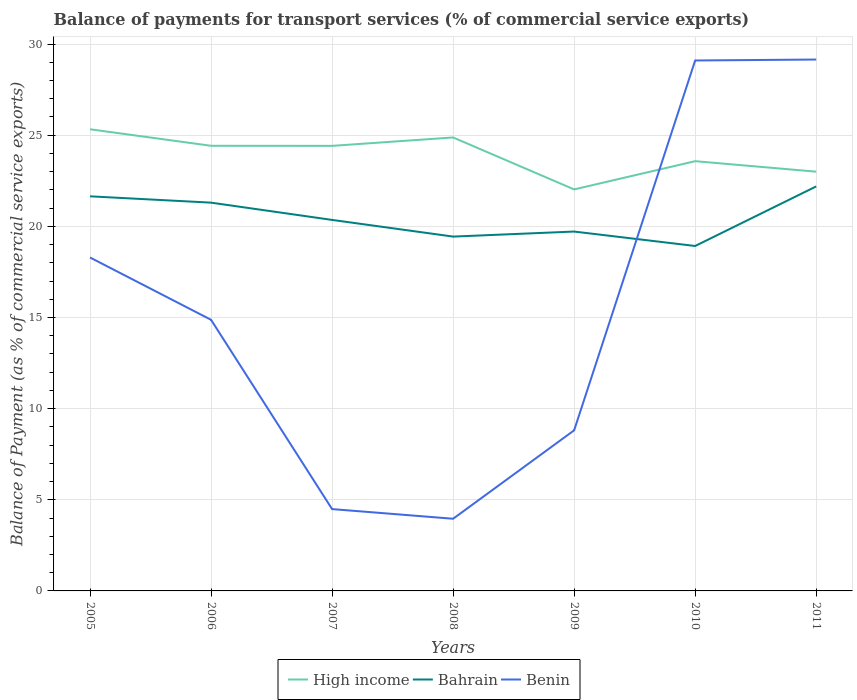Does the line corresponding to High income intersect with the line corresponding to Bahrain?
Make the answer very short. No. Is the number of lines equal to the number of legend labels?
Provide a short and direct response. Yes. Across all years, what is the maximum balance of payments for transport services in Benin?
Provide a succinct answer. 3.96. In which year was the balance of payments for transport services in High income maximum?
Your response must be concise. 2009. What is the total balance of payments for transport services in Benin in the graph?
Keep it short and to the point. -0.05. What is the difference between the highest and the second highest balance of payments for transport services in High income?
Ensure brevity in your answer.  3.3. How many lines are there?
Offer a very short reply. 3. What is the difference between two consecutive major ticks on the Y-axis?
Make the answer very short. 5. Where does the legend appear in the graph?
Your response must be concise. Bottom center. How are the legend labels stacked?
Your answer should be compact. Horizontal. What is the title of the graph?
Offer a very short reply. Balance of payments for transport services (% of commercial service exports). Does "Botswana" appear as one of the legend labels in the graph?
Give a very brief answer. No. What is the label or title of the X-axis?
Offer a terse response. Years. What is the label or title of the Y-axis?
Your response must be concise. Balance of Payment (as % of commercial service exports). What is the Balance of Payment (as % of commercial service exports) of High income in 2005?
Make the answer very short. 25.33. What is the Balance of Payment (as % of commercial service exports) in Bahrain in 2005?
Your response must be concise. 21.65. What is the Balance of Payment (as % of commercial service exports) of Benin in 2005?
Keep it short and to the point. 18.29. What is the Balance of Payment (as % of commercial service exports) of High income in 2006?
Your answer should be very brief. 24.42. What is the Balance of Payment (as % of commercial service exports) of Bahrain in 2006?
Your answer should be very brief. 21.3. What is the Balance of Payment (as % of commercial service exports) in Benin in 2006?
Your answer should be very brief. 14.87. What is the Balance of Payment (as % of commercial service exports) in High income in 2007?
Offer a very short reply. 24.42. What is the Balance of Payment (as % of commercial service exports) in Bahrain in 2007?
Your answer should be compact. 20.35. What is the Balance of Payment (as % of commercial service exports) of Benin in 2007?
Make the answer very short. 4.49. What is the Balance of Payment (as % of commercial service exports) in High income in 2008?
Offer a very short reply. 24.88. What is the Balance of Payment (as % of commercial service exports) of Bahrain in 2008?
Offer a very short reply. 19.44. What is the Balance of Payment (as % of commercial service exports) in Benin in 2008?
Give a very brief answer. 3.96. What is the Balance of Payment (as % of commercial service exports) in High income in 2009?
Make the answer very short. 22.03. What is the Balance of Payment (as % of commercial service exports) of Bahrain in 2009?
Offer a very short reply. 19.72. What is the Balance of Payment (as % of commercial service exports) of Benin in 2009?
Your response must be concise. 8.81. What is the Balance of Payment (as % of commercial service exports) in High income in 2010?
Your response must be concise. 23.58. What is the Balance of Payment (as % of commercial service exports) of Bahrain in 2010?
Give a very brief answer. 18.92. What is the Balance of Payment (as % of commercial service exports) of Benin in 2010?
Give a very brief answer. 29.1. What is the Balance of Payment (as % of commercial service exports) of High income in 2011?
Your response must be concise. 23. What is the Balance of Payment (as % of commercial service exports) in Bahrain in 2011?
Make the answer very short. 22.19. What is the Balance of Payment (as % of commercial service exports) in Benin in 2011?
Offer a very short reply. 29.15. Across all years, what is the maximum Balance of Payment (as % of commercial service exports) in High income?
Provide a short and direct response. 25.33. Across all years, what is the maximum Balance of Payment (as % of commercial service exports) of Bahrain?
Offer a terse response. 22.19. Across all years, what is the maximum Balance of Payment (as % of commercial service exports) of Benin?
Provide a short and direct response. 29.15. Across all years, what is the minimum Balance of Payment (as % of commercial service exports) in High income?
Your response must be concise. 22.03. Across all years, what is the minimum Balance of Payment (as % of commercial service exports) in Bahrain?
Make the answer very short. 18.92. Across all years, what is the minimum Balance of Payment (as % of commercial service exports) of Benin?
Your response must be concise. 3.96. What is the total Balance of Payment (as % of commercial service exports) in High income in the graph?
Make the answer very short. 167.64. What is the total Balance of Payment (as % of commercial service exports) of Bahrain in the graph?
Offer a terse response. 143.57. What is the total Balance of Payment (as % of commercial service exports) of Benin in the graph?
Offer a very short reply. 108.68. What is the difference between the Balance of Payment (as % of commercial service exports) in High income in 2005 and that in 2006?
Your answer should be very brief. 0.91. What is the difference between the Balance of Payment (as % of commercial service exports) in Bahrain in 2005 and that in 2006?
Your answer should be compact. 0.35. What is the difference between the Balance of Payment (as % of commercial service exports) of Benin in 2005 and that in 2006?
Your answer should be very brief. 3.42. What is the difference between the Balance of Payment (as % of commercial service exports) in High income in 2005 and that in 2007?
Offer a terse response. 0.91. What is the difference between the Balance of Payment (as % of commercial service exports) of Bahrain in 2005 and that in 2007?
Give a very brief answer. 1.29. What is the difference between the Balance of Payment (as % of commercial service exports) of Benin in 2005 and that in 2007?
Provide a succinct answer. 13.8. What is the difference between the Balance of Payment (as % of commercial service exports) in High income in 2005 and that in 2008?
Your answer should be very brief. 0.45. What is the difference between the Balance of Payment (as % of commercial service exports) of Bahrain in 2005 and that in 2008?
Your response must be concise. 2.21. What is the difference between the Balance of Payment (as % of commercial service exports) in Benin in 2005 and that in 2008?
Ensure brevity in your answer.  14.33. What is the difference between the Balance of Payment (as % of commercial service exports) in High income in 2005 and that in 2009?
Offer a very short reply. 3.3. What is the difference between the Balance of Payment (as % of commercial service exports) of Bahrain in 2005 and that in 2009?
Ensure brevity in your answer.  1.93. What is the difference between the Balance of Payment (as % of commercial service exports) in Benin in 2005 and that in 2009?
Ensure brevity in your answer.  9.48. What is the difference between the Balance of Payment (as % of commercial service exports) of High income in 2005 and that in 2010?
Offer a very short reply. 1.75. What is the difference between the Balance of Payment (as % of commercial service exports) in Bahrain in 2005 and that in 2010?
Make the answer very short. 2.73. What is the difference between the Balance of Payment (as % of commercial service exports) of Benin in 2005 and that in 2010?
Make the answer very short. -10.81. What is the difference between the Balance of Payment (as % of commercial service exports) of High income in 2005 and that in 2011?
Keep it short and to the point. 2.33. What is the difference between the Balance of Payment (as % of commercial service exports) in Bahrain in 2005 and that in 2011?
Your answer should be compact. -0.54. What is the difference between the Balance of Payment (as % of commercial service exports) in Benin in 2005 and that in 2011?
Ensure brevity in your answer.  -10.86. What is the difference between the Balance of Payment (as % of commercial service exports) in High income in 2006 and that in 2007?
Provide a succinct answer. 0. What is the difference between the Balance of Payment (as % of commercial service exports) in Bahrain in 2006 and that in 2007?
Your answer should be very brief. 0.95. What is the difference between the Balance of Payment (as % of commercial service exports) of Benin in 2006 and that in 2007?
Make the answer very short. 10.38. What is the difference between the Balance of Payment (as % of commercial service exports) of High income in 2006 and that in 2008?
Provide a short and direct response. -0.46. What is the difference between the Balance of Payment (as % of commercial service exports) in Bahrain in 2006 and that in 2008?
Make the answer very short. 1.86. What is the difference between the Balance of Payment (as % of commercial service exports) in Benin in 2006 and that in 2008?
Your answer should be compact. 10.91. What is the difference between the Balance of Payment (as % of commercial service exports) of High income in 2006 and that in 2009?
Your answer should be compact. 2.39. What is the difference between the Balance of Payment (as % of commercial service exports) of Bahrain in 2006 and that in 2009?
Offer a terse response. 1.59. What is the difference between the Balance of Payment (as % of commercial service exports) of Benin in 2006 and that in 2009?
Ensure brevity in your answer.  6.06. What is the difference between the Balance of Payment (as % of commercial service exports) of High income in 2006 and that in 2010?
Offer a terse response. 0.84. What is the difference between the Balance of Payment (as % of commercial service exports) in Bahrain in 2006 and that in 2010?
Give a very brief answer. 2.38. What is the difference between the Balance of Payment (as % of commercial service exports) in Benin in 2006 and that in 2010?
Give a very brief answer. -14.23. What is the difference between the Balance of Payment (as % of commercial service exports) of High income in 2006 and that in 2011?
Give a very brief answer. 1.42. What is the difference between the Balance of Payment (as % of commercial service exports) in Bahrain in 2006 and that in 2011?
Ensure brevity in your answer.  -0.89. What is the difference between the Balance of Payment (as % of commercial service exports) in Benin in 2006 and that in 2011?
Provide a short and direct response. -14.28. What is the difference between the Balance of Payment (as % of commercial service exports) of High income in 2007 and that in 2008?
Your response must be concise. -0.46. What is the difference between the Balance of Payment (as % of commercial service exports) of Bahrain in 2007 and that in 2008?
Provide a succinct answer. 0.92. What is the difference between the Balance of Payment (as % of commercial service exports) of Benin in 2007 and that in 2008?
Offer a terse response. 0.53. What is the difference between the Balance of Payment (as % of commercial service exports) in High income in 2007 and that in 2009?
Your answer should be very brief. 2.39. What is the difference between the Balance of Payment (as % of commercial service exports) of Bahrain in 2007 and that in 2009?
Give a very brief answer. 0.64. What is the difference between the Balance of Payment (as % of commercial service exports) in Benin in 2007 and that in 2009?
Provide a short and direct response. -4.32. What is the difference between the Balance of Payment (as % of commercial service exports) of High income in 2007 and that in 2010?
Offer a terse response. 0.84. What is the difference between the Balance of Payment (as % of commercial service exports) of Bahrain in 2007 and that in 2010?
Offer a very short reply. 1.43. What is the difference between the Balance of Payment (as % of commercial service exports) of Benin in 2007 and that in 2010?
Provide a short and direct response. -24.61. What is the difference between the Balance of Payment (as % of commercial service exports) in High income in 2007 and that in 2011?
Offer a very short reply. 1.42. What is the difference between the Balance of Payment (as % of commercial service exports) in Bahrain in 2007 and that in 2011?
Give a very brief answer. -1.84. What is the difference between the Balance of Payment (as % of commercial service exports) of Benin in 2007 and that in 2011?
Provide a succinct answer. -24.66. What is the difference between the Balance of Payment (as % of commercial service exports) of High income in 2008 and that in 2009?
Offer a very short reply. 2.85. What is the difference between the Balance of Payment (as % of commercial service exports) in Bahrain in 2008 and that in 2009?
Offer a very short reply. -0.28. What is the difference between the Balance of Payment (as % of commercial service exports) in Benin in 2008 and that in 2009?
Offer a very short reply. -4.85. What is the difference between the Balance of Payment (as % of commercial service exports) in High income in 2008 and that in 2010?
Your answer should be compact. 1.3. What is the difference between the Balance of Payment (as % of commercial service exports) in Bahrain in 2008 and that in 2010?
Your answer should be compact. 0.52. What is the difference between the Balance of Payment (as % of commercial service exports) of Benin in 2008 and that in 2010?
Offer a very short reply. -25.14. What is the difference between the Balance of Payment (as % of commercial service exports) of High income in 2008 and that in 2011?
Your response must be concise. 1.88. What is the difference between the Balance of Payment (as % of commercial service exports) in Bahrain in 2008 and that in 2011?
Keep it short and to the point. -2.75. What is the difference between the Balance of Payment (as % of commercial service exports) of Benin in 2008 and that in 2011?
Provide a short and direct response. -25.19. What is the difference between the Balance of Payment (as % of commercial service exports) in High income in 2009 and that in 2010?
Offer a very short reply. -1.55. What is the difference between the Balance of Payment (as % of commercial service exports) in Bahrain in 2009 and that in 2010?
Ensure brevity in your answer.  0.79. What is the difference between the Balance of Payment (as % of commercial service exports) in Benin in 2009 and that in 2010?
Offer a terse response. -20.29. What is the difference between the Balance of Payment (as % of commercial service exports) of High income in 2009 and that in 2011?
Ensure brevity in your answer.  -0.97. What is the difference between the Balance of Payment (as % of commercial service exports) in Bahrain in 2009 and that in 2011?
Give a very brief answer. -2.48. What is the difference between the Balance of Payment (as % of commercial service exports) in Benin in 2009 and that in 2011?
Give a very brief answer. -20.34. What is the difference between the Balance of Payment (as % of commercial service exports) in High income in 2010 and that in 2011?
Offer a very short reply. 0.58. What is the difference between the Balance of Payment (as % of commercial service exports) of Bahrain in 2010 and that in 2011?
Provide a succinct answer. -3.27. What is the difference between the Balance of Payment (as % of commercial service exports) in Benin in 2010 and that in 2011?
Your answer should be compact. -0.05. What is the difference between the Balance of Payment (as % of commercial service exports) in High income in 2005 and the Balance of Payment (as % of commercial service exports) in Bahrain in 2006?
Ensure brevity in your answer.  4.03. What is the difference between the Balance of Payment (as % of commercial service exports) in High income in 2005 and the Balance of Payment (as % of commercial service exports) in Benin in 2006?
Ensure brevity in your answer.  10.45. What is the difference between the Balance of Payment (as % of commercial service exports) in Bahrain in 2005 and the Balance of Payment (as % of commercial service exports) in Benin in 2006?
Keep it short and to the point. 6.77. What is the difference between the Balance of Payment (as % of commercial service exports) of High income in 2005 and the Balance of Payment (as % of commercial service exports) of Bahrain in 2007?
Your answer should be compact. 4.97. What is the difference between the Balance of Payment (as % of commercial service exports) in High income in 2005 and the Balance of Payment (as % of commercial service exports) in Benin in 2007?
Offer a terse response. 20.84. What is the difference between the Balance of Payment (as % of commercial service exports) in Bahrain in 2005 and the Balance of Payment (as % of commercial service exports) in Benin in 2007?
Your answer should be compact. 17.16. What is the difference between the Balance of Payment (as % of commercial service exports) in High income in 2005 and the Balance of Payment (as % of commercial service exports) in Bahrain in 2008?
Give a very brief answer. 5.89. What is the difference between the Balance of Payment (as % of commercial service exports) in High income in 2005 and the Balance of Payment (as % of commercial service exports) in Benin in 2008?
Provide a short and direct response. 21.37. What is the difference between the Balance of Payment (as % of commercial service exports) in Bahrain in 2005 and the Balance of Payment (as % of commercial service exports) in Benin in 2008?
Offer a very short reply. 17.69. What is the difference between the Balance of Payment (as % of commercial service exports) in High income in 2005 and the Balance of Payment (as % of commercial service exports) in Bahrain in 2009?
Provide a succinct answer. 5.61. What is the difference between the Balance of Payment (as % of commercial service exports) of High income in 2005 and the Balance of Payment (as % of commercial service exports) of Benin in 2009?
Offer a very short reply. 16.52. What is the difference between the Balance of Payment (as % of commercial service exports) in Bahrain in 2005 and the Balance of Payment (as % of commercial service exports) in Benin in 2009?
Offer a very short reply. 12.84. What is the difference between the Balance of Payment (as % of commercial service exports) in High income in 2005 and the Balance of Payment (as % of commercial service exports) in Bahrain in 2010?
Your response must be concise. 6.4. What is the difference between the Balance of Payment (as % of commercial service exports) in High income in 2005 and the Balance of Payment (as % of commercial service exports) in Benin in 2010?
Keep it short and to the point. -3.77. What is the difference between the Balance of Payment (as % of commercial service exports) in Bahrain in 2005 and the Balance of Payment (as % of commercial service exports) in Benin in 2010?
Provide a succinct answer. -7.45. What is the difference between the Balance of Payment (as % of commercial service exports) of High income in 2005 and the Balance of Payment (as % of commercial service exports) of Bahrain in 2011?
Offer a terse response. 3.13. What is the difference between the Balance of Payment (as % of commercial service exports) of High income in 2005 and the Balance of Payment (as % of commercial service exports) of Benin in 2011?
Provide a succinct answer. -3.83. What is the difference between the Balance of Payment (as % of commercial service exports) in Bahrain in 2005 and the Balance of Payment (as % of commercial service exports) in Benin in 2011?
Offer a terse response. -7.5. What is the difference between the Balance of Payment (as % of commercial service exports) of High income in 2006 and the Balance of Payment (as % of commercial service exports) of Bahrain in 2007?
Provide a succinct answer. 4.07. What is the difference between the Balance of Payment (as % of commercial service exports) of High income in 2006 and the Balance of Payment (as % of commercial service exports) of Benin in 2007?
Provide a succinct answer. 19.93. What is the difference between the Balance of Payment (as % of commercial service exports) in Bahrain in 2006 and the Balance of Payment (as % of commercial service exports) in Benin in 2007?
Offer a very short reply. 16.81. What is the difference between the Balance of Payment (as % of commercial service exports) in High income in 2006 and the Balance of Payment (as % of commercial service exports) in Bahrain in 2008?
Your answer should be very brief. 4.98. What is the difference between the Balance of Payment (as % of commercial service exports) in High income in 2006 and the Balance of Payment (as % of commercial service exports) in Benin in 2008?
Keep it short and to the point. 20.46. What is the difference between the Balance of Payment (as % of commercial service exports) in Bahrain in 2006 and the Balance of Payment (as % of commercial service exports) in Benin in 2008?
Make the answer very short. 17.34. What is the difference between the Balance of Payment (as % of commercial service exports) in High income in 2006 and the Balance of Payment (as % of commercial service exports) in Bahrain in 2009?
Your response must be concise. 4.7. What is the difference between the Balance of Payment (as % of commercial service exports) in High income in 2006 and the Balance of Payment (as % of commercial service exports) in Benin in 2009?
Your response must be concise. 15.61. What is the difference between the Balance of Payment (as % of commercial service exports) of Bahrain in 2006 and the Balance of Payment (as % of commercial service exports) of Benin in 2009?
Make the answer very short. 12.49. What is the difference between the Balance of Payment (as % of commercial service exports) of High income in 2006 and the Balance of Payment (as % of commercial service exports) of Bahrain in 2010?
Provide a short and direct response. 5.5. What is the difference between the Balance of Payment (as % of commercial service exports) of High income in 2006 and the Balance of Payment (as % of commercial service exports) of Benin in 2010?
Make the answer very short. -4.68. What is the difference between the Balance of Payment (as % of commercial service exports) of Bahrain in 2006 and the Balance of Payment (as % of commercial service exports) of Benin in 2010?
Ensure brevity in your answer.  -7.8. What is the difference between the Balance of Payment (as % of commercial service exports) in High income in 2006 and the Balance of Payment (as % of commercial service exports) in Bahrain in 2011?
Offer a very short reply. 2.23. What is the difference between the Balance of Payment (as % of commercial service exports) in High income in 2006 and the Balance of Payment (as % of commercial service exports) in Benin in 2011?
Ensure brevity in your answer.  -4.73. What is the difference between the Balance of Payment (as % of commercial service exports) in Bahrain in 2006 and the Balance of Payment (as % of commercial service exports) in Benin in 2011?
Provide a short and direct response. -7.85. What is the difference between the Balance of Payment (as % of commercial service exports) in High income in 2007 and the Balance of Payment (as % of commercial service exports) in Bahrain in 2008?
Your answer should be very brief. 4.98. What is the difference between the Balance of Payment (as % of commercial service exports) in High income in 2007 and the Balance of Payment (as % of commercial service exports) in Benin in 2008?
Offer a terse response. 20.46. What is the difference between the Balance of Payment (as % of commercial service exports) in Bahrain in 2007 and the Balance of Payment (as % of commercial service exports) in Benin in 2008?
Give a very brief answer. 16.39. What is the difference between the Balance of Payment (as % of commercial service exports) in High income in 2007 and the Balance of Payment (as % of commercial service exports) in Bahrain in 2009?
Keep it short and to the point. 4.7. What is the difference between the Balance of Payment (as % of commercial service exports) of High income in 2007 and the Balance of Payment (as % of commercial service exports) of Benin in 2009?
Your answer should be very brief. 15.61. What is the difference between the Balance of Payment (as % of commercial service exports) in Bahrain in 2007 and the Balance of Payment (as % of commercial service exports) in Benin in 2009?
Your answer should be compact. 11.54. What is the difference between the Balance of Payment (as % of commercial service exports) in High income in 2007 and the Balance of Payment (as % of commercial service exports) in Bahrain in 2010?
Keep it short and to the point. 5.49. What is the difference between the Balance of Payment (as % of commercial service exports) of High income in 2007 and the Balance of Payment (as % of commercial service exports) of Benin in 2010?
Offer a terse response. -4.68. What is the difference between the Balance of Payment (as % of commercial service exports) of Bahrain in 2007 and the Balance of Payment (as % of commercial service exports) of Benin in 2010?
Give a very brief answer. -8.75. What is the difference between the Balance of Payment (as % of commercial service exports) of High income in 2007 and the Balance of Payment (as % of commercial service exports) of Bahrain in 2011?
Give a very brief answer. 2.22. What is the difference between the Balance of Payment (as % of commercial service exports) of High income in 2007 and the Balance of Payment (as % of commercial service exports) of Benin in 2011?
Give a very brief answer. -4.74. What is the difference between the Balance of Payment (as % of commercial service exports) of Bahrain in 2007 and the Balance of Payment (as % of commercial service exports) of Benin in 2011?
Provide a succinct answer. -8.8. What is the difference between the Balance of Payment (as % of commercial service exports) in High income in 2008 and the Balance of Payment (as % of commercial service exports) in Bahrain in 2009?
Keep it short and to the point. 5.16. What is the difference between the Balance of Payment (as % of commercial service exports) in High income in 2008 and the Balance of Payment (as % of commercial service exports) in Benin in 2009?
Your response must be concise. 16.07. What is the difference between the Balance of Payment (as % of commercial service exports) in Bahrain in 2008 and the Balance of Payment (as % of commercial service exports) in Benin in 2009?
Your answer should be compact. 10.63. What is the difference between the Balance of Payment (as % of commercial service exports) of High income in 2008 and the Balance of Payment (as % of commercial service exports) of Bahrain in 2010?
Offer a terse response. 5.95. What is the difference between the Balance of Payment (as % of commercial service exports) in High income in 2008 and the Balance of Payment (as % of commercial service exports) in Benin in 2010?
Offer a very short reply. -4.22. What is the difference between the Balance of Payment (as % of commercial service exports) of Bahrain in 2008 and the Balance of Payment (as % of commercial service exports) of Benin in 2010?
Ensure brevity in your answer.  -9.66. What is the difference between the Balance of Payment (as % of commercial service exports) of High income in 2008 and the Balance of Payment (as % of commercial service exports) of Bahrain in 2011?
Give a very brief answer. 2.69. What is the difference between the Balance of Payment (as % of commercial service exports) in High income in 2008 and the Balance of Payment (as % of commercial service exports) in Benin in 2011?
Offer a very short reply. -4.28. What is the difference between the Balance of Payment (as % of commercial service exports) of Bahrain in 2008 and the Balance of Payment (as % of commercial service exports) of Benin in 2011?
Make the answer very short. -9.71. What is the difference between the Balance of Payment (as % of commercial service exports) in High income in 2009 and the Balance of Payment (as % of commercial service exports) in Bahrain in 2010?
Give a very brief answer. 3.1. What is the difference between the Balance of Payment (as % of commercial service exports) in High income in 2009 and the Balance of Payment (as % of commercial service exports) in Benin in 2010?
Your response must be concise. -7.07. What is the difference between the Balance of Payment (as % of commercial service exports) in Bahrain in 2009 and the Balance of Payment (as % of commercial service exports) in Benin in 2010?
Provide a succinct answer. -9.38. What is the difference between the Balance of Payment (as % of commercial service exports) of High income in 2009 and the Balance of Payment (as % of commercial service exports) of Bahrain in 2011?
Your answer should be very brief. -0.16. What is the difference between the Balance of Payment (as % of commercial service exports) of High income in 2009 and the Balance of Payment (as % of commercial service exports) of Benin in 2011?
Provide a succinct answer. -7.13. What is the difference between the Balance of Payment (as % of commercial service exports) in Bahrain in 2009 and the Balance of Payment (as % of commercial service exports) in Benin in 2011?
Provide a succinct answer. -9.44. What is the difference between the Balance of Payment (as % of commercial service exports) of High income in 2010 and the Balance of Payment (as % of commercial service exports) of Bahrain in 2011?
Provide a short and direct response. 1.38. What is the difference between the Balance of Payment (as % of commercial service exports) of High income in 2010 and the Balance of Payment (as % of commercial service exports) of Benin in 2011?
Your answer should be very brief. -5.58. What is the difference between the Balance of Payment (as % of commercial service exports) in Bahrain in 2010 and the Balance of Payment (as % of commercial service exports) in Benin in 2011?
Give a very brief answer. -10.23. What is the average Balance of Payment (as % of commercial service exports) of High income per year?
Keep it short and to the point. 23.95. What is the average Balance of Payment (as % of commercial service exports) of Bahrain per year?
Provide a short and direct response. 20.51. What is the average Balance of Payment (as % of commercial service exports) of Benin per year?
Provide a succinct answer. 15.53. In the year 2005, what is the difference between the Balance of Payment (as % of commercial service exports) in High income and Balance of Payment (as % of commercial service exports) in Bahrain?
Give a very brief answer. 3.68. In the year 2005, what is the difference between the Balance of Payment (as % of commercial service exports) in High income and Balance of Payment (as % of commercial service exports) in Benin?
Your response must be concise. 7.03. In the year 2005, what is the difference between the Balance of Payment (as % of commercial service exports) of Bahrain and Balance of Payment (as % of commercial service exports) of Benin?
Your response must be concise. 3.36. In the year 2006, what is the difference between the Balance of Payment (as % of commercial service exports) in High income and Balance of Payment (as % of commercial service exports) in Bahrain?
Make the answer very short. 3.12. In the year 2006, what is the difference between the Balance of Payment (as % of commercial service exports) of High income and Balance of Payment (as % of commercial service exports) of Benin?
Offer a very short reply. 9.55. In the year 2006, what is the difference between the Balance of Payment (as % of commercial service exports) of Bahrain and Balance of Payment (as % of commercial service exports) of Benin?
Offer a very short reply. 6.43. In the year 2007, what is the difference between the Balance of Payment (as % of commercial service exports) in High income and Balance of Payment (as % of commercial service exports) in Bahrain?
Ensure brevity in your answer.  4.06. In the year 2007, what is the difference between the Balance of Payment (as % of commercial service exports) of High income and Balance of Payment (as % of commercial service exports) of Benin?
Give a very brief answer. 19.93. In the year 2007, what is the difference between the Balance of Payment (as % of commercial service exports) in Bahrain and Balance of Payment (as % of commercial service exports) in Benin?
Provide a succinct answer. 15.86. In the year 2008, what is the difference between the Balance of Payment (as % of commercial service exports) in High income and Balance of Payment (as % of commercial service exports) in Bahrain?
Offer a terse response. 5.44. In the year 2008, what is the difference between the Balance of Payment (as % of commercial service exports) of High income and Balance of Payment (as % of commercial service exports) of Benin?
Make the answer very short. 20.92. In the year 2008, what is the difference between the Balance of Payment (as % of commercial service exports) of Bahrain and Balance of Payment (as % of commercial service exports) of Benin?
Your response must be concise. 15.48. In the year 2009, what is the difference between the Balance of Payment (as % of commercial service exports) in High income and Balance of Payment (as % of commercial service exports) in Bahrain?
Offer a terse response. 2.31. In the year 2009, what is the difference between the Balance of Payment (as % of commercial service exports) in High income and Balance of Payment (as % of commercial service exports) in Benin?
Your response must be concise. 13.22. In the year 2009, what is the difference between the Balance of Payment (as % of commercial service exports) of Bahrain and Balance of Payment (as % of commercial service exports) of Benin?
Keep it short and to the point. 10.9. In the year 2010, what is the difference between the Balance of Payment (as % of commercial service exports) in High income and Balance of Payment (as % of commercial service exports) in Bahrain?
Offer a very short reply. 4.65. In the year 2010, what is the difference between the Balance of Payment (as % of commercial service exports) in High income and Balance of Payment (as % of commercial service exports) in Benin?
Give a very brief answer. -5.52. In the year 2010, what is the difference between the Balance of Payment (as % of commercial service exports) of Bahrain and Balance of Payment (as % of commercial service exports) of Benin?
Keep it short and to the point. -10.18. In the year 2011, what is the difference between the Balance of Payment (as % of commercial service exports) of High income and Balance of Payment (as % of commercial service exports) of Bahrain?
Make the answer very short. 0.81. In the year 2011, what is the difference between the Balance of Payment (as % of commercial service exports) in High income and Balance of Payment (as % of commercial service exports) in Benin?
Your response must be concise. -6.15. In the year 2011, what is the difference between the Balance of Payment (as % of commercial service exports) in Bahrain and Balance of Payment (as % of commercial service exports) in Benin?
Provide a succinct answer. -6.96. What is the ratio of the Balance of Payment (as % of commercial service exports) in High income in 2005 to that in 2006?
Provide a succinct answer. 1.04. What is the ratio of the Balance of Payment (as % of commercial service exports) of Bahrain in 2005 to that in 2006?
Give a very brief answer. 1.02. What is the ratio of the Balance of Payment (as % of commercial service exports) of Benin in 2005 to that in 2006?
Keep it short and to the point. 1.23. What is the ratio of the Balance of Payment (as % of commercial service exports) in High income in 2005 to that in 2007?
Offer a terse response. 1.04. What is the ratio of the Balance of Payment (as % of commercial service exports) in Bahrain in 2005 to that in 2007?
Offer a very short reply. 1.06. What is the ratio of the Balance of Payment (as % of commercial service exports) in Benin in 2005 to that in 2007?
Make the answer very short. 4.07. What is the ratio of the Balance of Payment (as % of commercial service exports) of High income in 2005 to that in 2008?
Make the answer very short. 1.02. What is the ratio of the Balance of Payment (as % of commercial service exports) in Bahrain in 2005 to that in 2008?
Your answer should be compact. 1.11. What is the ratio of the Balance of Payment (as % of commercial service exports) of Benin in 2005 to that in 2008?
Give a very brief answer. 4.62. What is the ratio of the Balance of Payment (as % of commercial service exports) in High income in 2005 to that in 2009?
Your answer should be very brief. 1.15. What is the ratio of the Balance of Payment (as % of commercial service exports) of Bahrain in 2005 to that in 2009?
Your answer should be compact. 1.1. What is the ratio of the Balance of Payment (as % of commercial service exports) of Benin in 2005 to that in 2009?
Ensure brevity in your answer.  2.08. What is the ratio of the Balance of Payment (as % of commercial service exports) of High income in 2005 to that in 2010?
Provide a succinct answer. 1.07. What is the ratio of the Balance of Payment (as % of commercial service exports) of Bahrain in 2005 to that in 2010?
Give a very brief answer. 1.14. What is the ratio of the Balance of Payment (as % of commercial service exports) in Benin in 2005 to that in 2010?
Offer a very short reply. 0.63. What is the ratio of the Balance of Payment (as % of commercial service exports) of High income in 2005 to that in 2011?
Your answer should be very brief. 1.1. What is the ratio of the Balance of Payment (as % of commercial service exports) in Bahrain in 2005 to that in 2011?
Give a very brief answer. 0.98. What is the ratio of the Balance of Payment (as % of commercial service exports) of Benin in 2005 to that in 2011?
Provide a succinct answer. 0.63. What is the ratio of the Balance of Payment (as % of commercial service exports) of Bahrain in 2006 to that in 2007?
Make the answer very short. 1.05. What is the ratio of the Balance of Payment (as % of commercial service exports) in Benin in 2006 to that in 2007?
Offer a terse response. 3.31. What is the ratio of the Balance of Payment (as % of commercial service exports) in High income in 2006 to that in 2008?
Make the answer very short. 0.98. What is the ratio of the Balance of Payment (as % of commercial service exports) of Bahrain in 2006 to that in 2008?
Give a very brief answer. 1.1. What is the ratio of the Balance of Payment (as % of commercial service exports) in Benin in 2006 to that in 2008?
Provide a succinct answer. 3.76. What is the ratio of the Balance of Payment (as % of commercial service exports) in High income in 2006 to that in 2009?
Offer a very short reply. 1.11. What is the ratio of the Balance of Payment (as % of commercial service exports) in Bahrain in 2006 to that in 2009?
Provide a short and direct response. 1.08. What is the ratio of the Balance of Payment (as % of commercial service exports) in Benin in 2006 to that in 2009?
Keep it short and to the point. 1.69. What is the ratio of the Balance of Payment (as % of commercial service exports) of High income in 2006 to that in 2010?
Provide a short and direct response. 1.04. What is the ratio of the Balance of Payment (as % of commercial service exports) in Bahrain in 2006 to that in 2010?
Your response must be concise. 1.13. What is the ratio of the Balance of Payment (as % of commercial service exports) in Benin in 2006 to that in 2010?
Offer a very short reply. 0.51. What is the ratio of the Balance of Payment (as % of commercial service exports) of High income in 2006 to that in 2011?
Provide a short and direct response. 1.06. What is the ratio of the Balance of Payment (as % of commercial service exports) of Bahrain in 2006 to that in 2011?
Offer a very short reply. 0.96. What is the ratio of the Balance of Payment (as % of commercial service exports) of Benin in 2006 to that in 2011?
Provide a short and direct response. 0.51. What is the ratio of the Balance of Payment (as % of commercial service exports) of High income in 2007 to that in 2008?
Keep it short and to the point. 0.98. What is the ratio of the Balance of Payment (as % of commercial service exports) in Bahrain in 2007 to that in 2008?
Your answer should be compact. 1.05. What is the ratio of the Balance of Payment (as % of commercial service exports) of Benin in 2007 to that in 2008?
Your answer should be very brief. 1.13. What is the ratio of the Balance of Payment (as % of commercial service exports) of High income in 2007 to that in 2009?
Your answer should be compact. 1.11. What is the ratio of the Balance of Payment (as % of commercial service exports) of Bahrain in 2007 to that in 2009?
Offer a very short reply. 1.03. What is the ratio of the Balance of Payment (as % of commercial service exports) in Benin in 2007 to that in 2009?
Provide a succinct answer. 0.51. What is the ratio of the Balance of Payment (as % of commercial service exports) of High income in 2007 to that in 2010?
Give a very brief answer. 1.04. What is the ratio of the Balance of Payment (as % of commercial service exports) in Bahrain in 2007 to that in 2010?
Your answer should be very brief. 1.08. What is the ratio of the Balance of Payment (as % of commercial service exports) of Benin in 2007 to that in 2010?
Keep it short and to the point. 0.15. What is the ratio of the Balance of Payment (as % of commercial service exports) in High income in 2007 to that in 2011?
Provide a succinct answer. 1.06. What is the ratio of the Balance of Payment (as % of commercial service exports) in Bahrain in 2007 to that in 2011?
Provide a succinct answer. 0.92. What is the ratio of the Balance of Payment (as % of commercial service exports) of Benin in 2007 to that in 2011?
Ensure brevity in your answer.  0.15. What is the ratio of the Balance of Payment (as % of commercial service exports) of High income in 2008 to that in 2009?
Your answer should be compact. 1.13. What is the ratio of the Balance of Payment (as % of commercial service exports) of Bahrain in 2008 to that in 2009?
Offer a very short reply. 0.99. What is the ratio of the Balance of Payment (as % of commercial service exports) of Benin in 2008 to that in 2009?
Your response must be concise. 0.45. What is the ratio of the Balance of Payment (as % of commercial service exports) of High income in 2008 to that in 2010?
Provide a short and direct response. 1.06. What is the ratio of the Balance of Payment (as % of commercial service exports) in Bahrain in 2008 to that in 2010?
Your answer should be compact. 1.03. What is the ratio of the Balance of Payment (as % of commercial service exports) of Benin in 2008 to that in 2010?
Provide a short and direct response. 0.14. What is the ratio of the Balance of Payment (as % of commercial service exports) of High income in 2008 to that in 2011?
Your response must be concise. 1.08. What is the ratio of the Balance of Payment (as % of commercial service exports) of Bahrain in 2008 to that in 2011?
Offer a very short reply. 0.88. What is the ratio of the Balance of Payment (as % of commercial service exports) in Benin in 2008 to that in 2011?
Ensure brevity in your answer.  0.14. What is the ratio of the Balance of Payment (as % of commercial service exports) of High income in 2009 to that in 2010?
Your answer should be very brief. 0.93. What is the ratio of the Balance of Payment (as % of commercial service exports) of Bahrain in 2009 to that in 2010?
Offer a very short reply. 1.04. What is the ratio of the Balance of Payment (as % of commercial service exports) of Benin in 2009 to that in 2010?
Provide a succinct answer. 0.3. What is the ratio of the Balance of Payment (as % of commercial service exports) in High income in 2009 to that in 2011?
Provide a short and direct response. 0.96. What is the ratio of the Balance of Payment (as % of commercial service exports) of Bahrain in 2009 to that in 2011?
Provide a succinct answer. 0.89. What is the ratio of the Balance of Payment (as % of commercial service exports) in Benin in 2009 to that in 2011?
Offer a very short reply. 0.3. What is the ratio of the Balance of Payment (as % of commercial service exports) in High income in 2010 to that in 2011?
Give a very brief answer. 1.02. What is the ratio of the Balance of Payment (as % of commercial service exports) in Bahrain in 2010 to that in 2011?
Your response must be concise. 0.85. What is the difference between the highest and the second highest Balance of Payment (as % of commercial service exports) in High income?
Keep it short and to the point. 0.45. What is the difference between the highest and the second highest Balance of Payment (as % of commercial service exports) of Bahrain?
Give a very brief answer. 0.54. What is the difference between the highest and the second highest Balance of Payment (as % of commercial service exports) in Benin?
Provide a succinct answer. 0.05. What is the difference between the highest and the lowest Balance of Payment (as % of commercial service exports) of High income?
Provide a succinct answer. 3.3. What is the difference between the highest and the lowest Balance of Payment (as % of commercial service exports) of Bahrain?
Give a very brief answer. 3.27. What is the difference between the highest and the lowest Balance of Payment (as % of commercial service exports) in Benin?
Give a very brief answer. 25.19. 